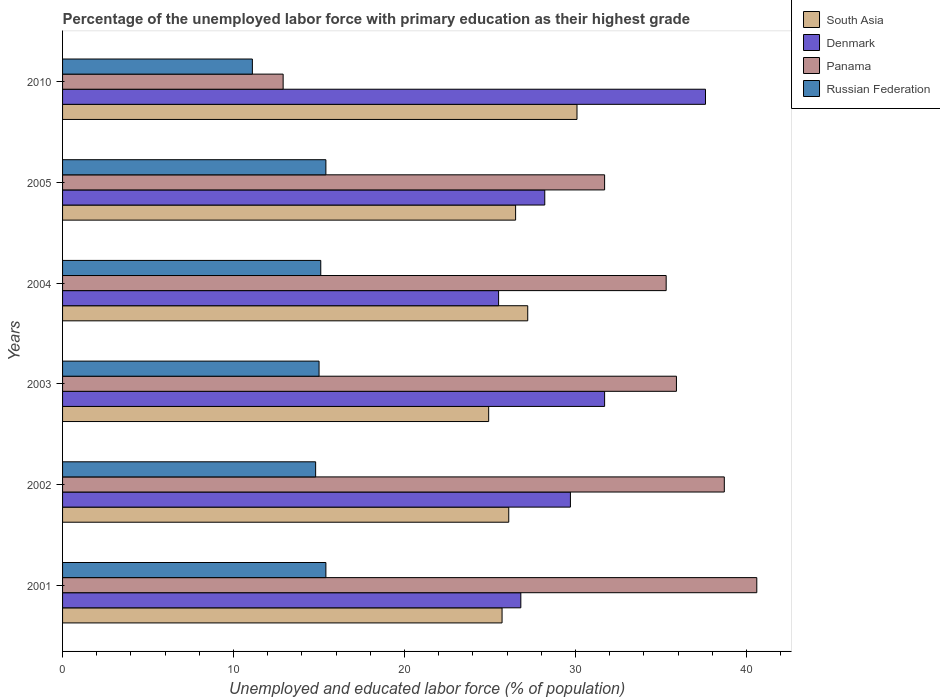How many different coloured bars are there?
Your answer should be very brief. 4. Are the number of bars per tick equal to the number of legend labels?
Make the answer very short. Yes. How many bars are there on the 4th tick from the top?
Offer a terse response. 4. How many bars are there on the 5th tick from the bottom?
Your answer should be very brief. 4. What is the label of the 6th group of bars from the top?
Offer a terse response. 2001. What is the percentage of the unemployed labor force with primary education in Denmark in 2010?
Your answer should be compact. 37.6. Across all years, what is the maximum percentage of the unemployed labor force with primary education in Russian Federation?
Provide a succinct answer. 15.4. Across all years, what is the minimum percentage of the unemployed labor force with primary education in South Asia?
Provide a short and direct response. 24.92. In which year was the percentage of the unemployed labor force with primary education in South Asia maximum?
Your response must be concise. 2010. What is the total percentage of the unemployed labor force with primary education in Denmark in the graph?
Your answer should be very brief. 179.5. What is the difference between the percentage of the unemployed labor force with primary education in Russian Federation in 2004 and that in 2010?
Ensure brevity in your answer.  4. What is the difference between the percentage of the unemployed labor force with primary education in Panama in 2005 and the percentage of the unemployed labor force with primary education in South Asia in 2001?
Give a very brief answer. 6. What is the average percentage of the unemployed labor force with primary education in Panama per year?
Your answer should be compact. 32.52. In the year 2003, what is the difference between the percentage of the unemployed labor force with primary education in Russian Federation and percentage of the unemployed labor force with primary education in Panama?
Provide a succinct answer. -20.9. What is the ratio of the percentage of the unemployed labor force with primary education in Denmark in 2005 to that in 2010?
Ensure brevity in your answer.  0.75. Is the percentage of the unemployed labor force with primary education in Denmark in 2001 less than that in 2004?
Give a very brief answer. No. What is the difference between the highest and the second highest percentage of the unemployed labor force with primary education in Denmark?
Offer a very short reply. 5.9. What is the difference between the highest and the lowest percentage of the unemployed labor force with primary education in South Asia?
Ensure brevity in your answer.  5.17. In how many years, is the percentage of the unemployed labor force with primary education in Denmark greater than the average percentage of the unemployed labor force with primary education in Denmark taken over all years?
Provide a succinct answer. 2. Is the sum of the percentage of the unemployed labor force with primary education in Panama in 2004 and 2005 greater than the maximum percentage of the unemployed labor force with primary education in Denmark across all years?
Ensure brevity in your answer.  Yes. What does the 2nd bar from the top in 2001 represents?
Your answer should be compact. Panama. What does the 1st bar from the bottom in 2003 represents?
Make the answer very short. South Asia. Are all the bars in the graph horizontal?
Give a very brief answer. Yes. What is the difference between two consecutive major ticks on the X-axis?
Your answer should be very brief. 10. Does the graph contain grids?
Your answer should be very brief. No. How many legend labels are there?
Ensure brevity in your answer.  4. How are the legend labels stacked?
Give a very brief answer. Vertical. What is the title of the graph?
Provide a short and direct response. Percentage of the unemployed labor force with primary education as their highest grade. Does "Vietnam" appear as one of the legend labels in the graph?
Make the answer very short. No. What is the label or title of the X-axis?
Offer a terse response. Unemployed and educated labor force (% of population). What is the label or title of the Y-axis?
Your response must be concise. Years. What is the Unemployed and educated labor force (% of population) in South Asia in 2001?
Your answer should be compact. 25.7. What is the Unemployed and educated labor force (% of population) of Denmark in 2001?
Keep it short and to the point. 26.8. What is the Unemployed and educated labor force (% of population) in Panama in 2001?
Provide a short and direct response. 40.6. What is the Unemployed and educated labor force (% of population) of Russian Federation in 2001?
Your answer should be compact. 15.4. What is the Unemployed and educated labor force (% of population) of South Asia in 2002?
Your answer should be very brief. 26.09. What is the Unemployed and educated labor force (% of population) of Denmark in 2002?
Offer a terse response. 29.7. What is the Unemployed and educated labor force (% of population) in Panama in 2002?
Offer a very short reply. 38.7. What is the Unemployed and educated labor force (% of population) of Russian Federation in 2002?
Make the answer very short. 14.8. What is the Unemployed and educated labor force (% of population) of South Asia in 2003?
Your answer should be compact. 24.92. What is the Unemployed and educated labor force (% of population) in Denmark in 2003?
Keep it short and to the point. 31.7. What is the Unemployed and educated labor force (% of population) in Panama in 2003?
Provide a short and direct response. 35.9. What is the Unemployed and educated labor force (% of population) in Russian Federation in 2003?
Your answer should be very brief. 15. What is the Unemployed and educated labor force (% of population) in South Asia in 2004?
Give a very brief answer. 27.2. What is the Unemployed and educated labor force (% of population) of Denmark in 2004?
Your answer should be compact. 25.5. What is the Unemployed and educated labor force (% of population) in Panama in 2004?
Your answer should be compact. 35.3. What is the Unemployed and educated labor force (% of population) of Russian Federation in 2004?
Provide a succinct answer. 15.1. What is the Unemployed and educated labor force (% of population) of South Asia in 2005?
Keep it short and to the point. 26.5. What is the Unemployed and educated labor force (% of population) of Denmark in 2005?
Give a very brief answer. 28.2. What is the Unemployed and educated labor force (% of population) of Panama in 2005?
Your response must be concise. 31.7. What is the Unemployed and educated labor force (% of population) of Russian Federation in 2005?
Give a very brief answer. 15.4. What is the Unemployed and educated labor force (% of population) in South Asia in 2010?
Give a very brief answer. 30.08. What is the Unemployed and educated labor force (% of population) in Denmark in 2010?
Your answer should be compact. 37.6. What is the Unemployed and educated labor force (% of population) in Panama in 2010?
Provide a succinct answer. 12.9. What is the Unemployed and educated labor force (% of population) of Russian Federation in 2010?
Give a very brief answer. 11.1. Across all years, what is the maximum Unemployed and educated labor force (% of population) of South Asia?
Make the answer very short. 30.08. Across all years, what is the maximum Unemployed and educated labor force (% of population) in Denmark?
Your answer should be compact. 37.6. Across all years, what is the maximum Unemployed and educated labor force (% of population) in Panama?
Provide a succinct answer. 40.6. Across all years, what is the maximum Unemployed and educated labor force (% of population) in Russian Federation?
Provide a succinct answer. 15.4. Across all years, what is the minimum Unemployed and educated labor force (% of population) of South Asia?
Provide a short and direct response. 24.92. Across all years, what is the minimum Unemployed and educated labor force (% of population) in Denmark?
Provide a short and direct response. 25.5. Across all years, what is the minimum Unemployed and educated labor force (% of population) in Panama?
Your answer should be very brief. 12.9. Across all years, what is the minimum Unemployed and educated labor force (% of population) in Russian Federation?
Provide a succinct answer. 11.1. What is the total Unemployed and educated labor force (% of population) in South Asia in the graph?
Provide a succinct answer. 160.5. What is the total Unemployed and educated labor force (% of population) in Denmark in the graph?
Ensure brevity in your answer.  179.5. What is the total Unemployed and educated labor force (% of population) of Panama in the graph?
Offer a terse response. 195.1. What is the total Unemployed and educated labor force (% of population) of Russian Federation in the graph?
Make the answer very short. 86.8. What is the difference between the Unemployed and educated labor force (% of population) of South Asia in 2001 and that in 2002?
Keep it short and to the point. -0.39. What is the difference between the Unemployed and educated labor force (% of population) of Denmark in 2001 and that in 2002?
Keep it short and to the point. -2.9. What is the difference between the Unemployed and educated labor force (% of population) in South Asia in 2001 and that in 2003?
Your answer should be very brief. 0.78. What is the difference between the Unemployed and educated labor force (% of population) in South Asia in 2001 and that in 2004?
Make the answer very short. -1.5. What is the difference between the Unemployed and educated labor force (% of population) in Panama in 2001 and that in 2004?
Your answer should be compact. 5.3. What is the difference between the Unemployed and educated labor force (% of population) in Russian Federation in 2001 and that in 2004?
Your answer should be very brief. 0.3. What is the difference between the Unemployed and educated labor force (% of population) of South Asia in 2001 and that in 2005?
Your answer should be compact. -0.79. What is the difference between the Unemployed and educated labor force (% of population) of Panama in 2001 and that in 2005?
Give a very brief answer. 8.9. What is the difference between the Unemployed and educated labor force (% of population) in South Asia in 2001 and that in 2010?
Ensure brevity in your answer.  -4.38. What is the difference between the Unemployed and educated labor force (% of population) in Denmark in 2001 and that in 2010?
Keep it short and to the point. -10.8. What is the difference between the Unemployed and educated labor force (% of population) of Panama in 2001 and that in 2010?
Offer a terse response. 27.7. What is the difference between the Unemployed and educated labor force (% of population) in South Asia in 2002 and that in 2003?
Offer a very short reply. 1.17. What is the difference between the Unemployed and educated labor force (% of population) in Denmark in 2002 and that in 2003?
Give a very brief answer. -2. What is the difference between the Unemployed and educated labor force (% of population) of Russian Federation in 2002 and that in 2003?
Your answer should be compact. -0.2. What is the difference between the Unemployed and educated labor force (% of population) in South Asia in 2002 and that in 2004?
Give a very brief answer. -1.11. What is the difference between the Unemployed and educated labor force (% of population) in Denmark in 2002 and that in 2004?
Make the answer very short. 4.2. What is the difference between the Unemployed and educated labor force (% of population) in Panama in 2002 and that in 2004?
Offer a very short reply. 3.4. What is the difference between the Unemployed and educated labor force (% of population) in Russian Federation in 2002 and that in 2004?
Offer a terse response. -0.3. What is the difference between the Unemployed and educated labor force (% of population) of South Asia in 2002 and that in 2005?
Make the answer very short. -0.4. What is the difference between the Unemployed and educated labor force (% of population) of South Asia in 2002 and that in 2010?
Provide a short and direct response. -3.99. What is the difference between the Unemployed and educated labor force (% of population) in Denmark in 2002 and that in 2010?
Offer a very short reply. -7.9. What is the difference between the Unemployed and educated labor force (% of population) of Panama in 2002 and that in 2010?
Provide a succinct answer. 25.8. What is the difference between the Unemployed and educated labor force (% of population) in South Asia in 2003 and that in 2004?
Keep it short and to the point. -2.28. What is the difference between the Unemployed and educated labor force (% of population) of Denmark in 2003 and that in 2004?
Ensure brevity in your answer.  6.2. What is the difference between the Unemployed and educated labor force (% of population) of Russian Federation in 2003 and that in 2004?
Make the answer very short. -0.1. What is the difference between the Unemployed and educated labor force (% of population) of South Asia in 2003 and that in 2005?
Give a very brief answer. -1.58. What is the difference between the Unemployed and educated labor force (% of population) in Panama in 2003 and that in 2005?
Provide a short and direct response. 4.2. What is the difference between the Unemployed and educated labor force (% of population) in Russian Federation in 2003 and that in 2005?
Offer a terse response. -0.4. What is the difference between the Unemployed and educated labor force (% of population) of South Asia in 2003 and that in 2010?
Give a very brief answer. -5.17. What is the difference between the Unemployed and educated labor force (% of population) in Denmark in 2003 and that in 2010?
Provide a succinct answer. -5.9. What is the difference between the Unemployed and educated labor force (% of population) of Panama in 2003 and that in 2010?
Give a very brief answer. 23. What is the difference between the Unemployed and educated labor force (% of population) of Russian Federation in 2003 and that in 2010?
Your response must be concise. 3.9. What is the difference between the Unemployed and educated labor force (% of population) in South Asia in 2004 and that in 2005?
Your answer should be compact. 0.71. What is the difference between the Unemployed and educated labor force (% of population) of Denmark in 2004 and that in 2005?
Your answer should be very brief. -2.7. What is the difference between the Unemployed and educated labor force (% of population) in Panama in 2004 and that in 2005?
Give a very brief answer. 3.6. What is the difference between the Unemployed and educated labor force (% of population) in South Asia in 2004 and that in 2010?
Provide a succinct answer. -2.88. What is the difference between the Unemployed and educated labor force (% of population) of Denmark in 2004 and that in 2010?
Keep it short and to the point. -12.1. What is the difference between the Unemployed and educated labor force (% of population) of Panama in 2004 and that in 2010?
Your response must be concise. 22.4. What is the difference between the Unemployed and educated labor force (% of population) of Russian Federation in 2004 and that in 2010?
Provide a short and direct response. 4. What is the difference between the Unemployed and educated labor force (% of population) in South Asia in 2005 and that in 2010?
Provide a short and direct response. -3.59. What is the difference between the Unemployed and educated labor force (% of population) of Denmark in 2005 and that in 2010?
Keep it short and to the point. -9.4. What is the difference between the Unemployed and educated labor force (% of population) in Panama in 2005 and that in 2010?
Give a very brief answer. 18.8. What is the difference between the Unemployed and educated labor force (% of population) of South Asia in 2001 and the Unemployed and educated labor force (% of population) of Denmark in 2002?
Your response must be concise. -4. What is the difference between the Unemployed and educated labor force (% of population) of South Asia in 2001 and the Unemployed and educated labor force (% of population) of Panama in 2002?
Provide a short and direct response. -13. What is the difference between the Unemployed and educated labor force (% of population) of South Asia in 2001 and the Unemployed and educated labor force (% of population) of Russian Federation in 2002?
Give a very brief answer. 10.9. What is the difference between the Unemployed and educated labor force (% of population) in Denmark in 2001 and the Unemployed and educated labor force (% of population) in Russian Federation in 2002?
Your answer should be compact. 12. What is the difference between the Unemployed and educated labor force (% of population) of Panama in 2001 and the Unemployed and educated labor force (% of population) of Russian Federation in 2002?
Provide a succinct answer. 25.8. What is the difference between the Unemployed and educated labor force (% of population) of South Asia in 2001 and the Unemployed and educated labor force (% of population) of Denmark in 2003?
Provide a succinct answer. -6. What is the difference between the Unemployed and educated labor force (% of population) of South Asia in 2001 and the Unemployed and educated labor force (% of population) of Panama in 2003?
Ensure brevity in your answer.  -10.2. What is the difference between the Unemployed and educated labor force (% of population) in South Asia in 2001 and the Unemployed and educated labor force (% of population) in Russian Federation in 2003?
Your answer should be compact. 10.7. What is the difference between the Unemployed and educated labor force (% of population) in Denmark in 2001 and the Unemployed and educated labor force (% of population) in Russian Federation in 2003?
Provide a short and direct response. 11.8. What is the difference between the Unemployed and educated labor force (% of population) of Panama in 2001 and the Unemployed and educated labor force (% of population) of Russian Federation in 2003?
Make the answer very short. 25.6. What is the difference between the Unemployed and educated labor force (% of population) of South Asia in 2001 and the Unemployed and educated labor force (% of population) of Denmark in 2004?
Keep it short and to the point. 0.2. What is the difference between the Unemployed and educated labor force (% of population) in South Asia in 2001 and the Unemployed and educated labor force (% of population) in Panama in 2004?
Provide a short and direct response. -9.6. What is the difference between the Unemployed and educated labor force (% of population) in South Asia in 2001 and the Unemployed and educated labor force (% of population) in Russian Federation in 2004?
Your response must be concise. 10.6. What is the difference between the Unemployed and educated labor force (% of population) of Panama in 2001 and the Unemployed and educated labor force (% of population) of Russian Federation in 2004?
Your response must be concise. 25.5. What is the difference between the Unemployed and educated labor force (% of population) of South Asia in 2001 and the Unemployed and educated labor force (% of population) of Denmark in 2005?
Your answer should be very brief. -2.5. What is the difference between the Unemployed and educated labor force (% of population) of South Asia in 2001 and the Unemployed and educated labor force (% of population) of Panama in 2005?
Provide a succinct answer. -6. What is the difference between the Unemployed and educated labor force (% of population) in South Asia in 2001 and the Unemployed and educated labor force (% of population) in Russian Federation in 2005?
Give a very brief answer. 10.3. What is the difference between the Unemployed and educated labor force (% of population) in Denmark in 2001 and the Unemployed and educated labor force (% of population) in Panama in 2005?
Offer a very short reply. -4.9. What is the difference between the Unemployed and educated labor force (% of population) of Panama in 2001 and the Unemployed and educated labor force (% of population) of Russian Federation in 2005?
Ensure brevity in your answer.  25.2. What is the difference between the Unemployed and educated labor force (% of population) of South Asia in 2001 and the Unemployed and educated labor force (% of population) of Denmark in 2010?
Your response must be concise. -11.9. What is the difference between the Unemployed and educated labor force (% of population) in South Asia in 2001 and the Unemployed and educated labor force (% of population) in Panama in 2010?
Ensure brevity in your answer.  12.8. What is the difference between the Unemployed and educated labor force (% of population) in South Asia in 2001 and the Unemployed and educated labor force (% of population) in Russian Federation in 2010?
Offer a very short reply. 14.6. What is the difference between the Unemployed and educated labor force (% of population) in Panama in 2001 and the Unemployed and educated labor force (% of population) in Russian Federation in 2010?
Provide a short and direct response. 29.5. What is the difference between the Unemployed and educated labor force (% of population) in South Asia in 2002 and the Unemployed and educated labor force (% of population) in Denmark in 2003?
Ensure brevity in your answer.  -5.61. What is the difference between the Unemployed and educated labor force (% of population) in South Asia in 2002 and the Unemployed and educated labor force (% of population) in Panama in 2003?
Provide a succinct answer. -9.81. What is the difference between the Unemployed and educated labor force (% of population) of South Asia in 2002 and the Unemployed and educated labor force (% of population) of Russian Federation in 2003?
Your response must be concise. 11.09. What is the difference between the Unemployed and educated labor force (% of population) in Panama in 2002 and the Unemployed and educated labor force (% of population) in Russian Federation in 2003?
Provide a short and direct response. 23.7. What is the difference between the Unemployed and educated labor force (% of population) of South Asia in 2002 and the Unemployed and educated labor force (% of population) of Denmark in 2004?
Ensure brevity in your answer.  0.59. What is the difference between the Unemployed and educated labor force (% of population) in South Asia in 2002 and the Unemployed and educated labor force (% of population) in Panama in 2004?
Offer a terse response. -9.21. What is the difference between the Unemployed and educated labor force (% of population) of South Asia in 2002 and the Unemployed and educated labor force (% of population) of Russian Federation in 2004?
Your response must be concise. 10.99. What is the difference between the Unemployed and educated labor force (% of population) in Denmark in 2002 and the Unemployed and educated labor force (% of population) in Panama in 2004?
Your answer should be compact. -5.6. What is the difference between the Unemployed and educated labor force (% of population) in Panama in 2002 and the Unemployed and educated labor force (% of population) in Russian Federation in 2004?
Offer a terse response. 23.6. What is the difference between the Unemployed and educated labor force (% of population) in South Asia in 2002 and the Unemployed and educated labor force (% of population) in Denmark in 2005?
Give a very brief answer. -2.11. What is the difference between the Unemployed and educated labor force (% of population) in South Asia in 2002 and the Unemployed and educated labor force (% of population) in Panama in 2005?
Provide a succinct answer. -5.61. What is the difference between the Unemployed and educated labor force (% of population) in South Asia in 2002 and the Unemployed and educated labor force (% of population) in Russian Federation in 2005?
Offer a terse response. 10.69. What is the difference between the Unemployed and educated labor force (% of population) of Denmark in 2002 and the Unemployed and educated labor force (% of population) of Panama in 2005?
Provide a short and direct response. -2. What is the difference between the Unemployed and educated labor force (% of population) of Panama in 2002 and the Unemployed and educated labor force (% of population) of Russian Federation in 2005?
Provide a short and direct response. 23.3. What is the difference between the Unemployed and educated labor force (% of population) in South Asia in 2002 and the Unemployed and educated labor force (% of population) in Denmark in 2010?
Keep it short and to the point. -11.51. What is the difference between the Unemployed and educated labor force (% of population) of South Asia in 2002 and the Unemployed and educated labor force (% of population) of Panama in 2010?
Ensure brevity in your answer.  13.19. What is the difference between the Unemployed and educated labor force (% of population) of South Asia in 2002 and the Unemployed and educated labor force (% of population) of Russian Federation in 2010?
Your answer should be compact. 14.99. What is the difference between the Unemployed and educated labor force (% of population) of Denmark in 2002 and the Unemployed and educated labor force (% of population) of Russian Federation in 2010?
Offer a terse response. 18.6. What is the difference between the Unemployed and educated labor force (% of population) of Panama in 2002 and the Unemployed and educated labor force (% of population) of Russian Federation in 2010?
Your answer should be compact. 27.6. What is the difference between the Unemployed and educated labor force (% of population) in South Asia in 2003 and the Unemployed and educated labor force (% of population) in Denmark in 2004?
Provide a succinct answer. -0.58. What is the difference between the Unemployed and educated labor force (% of population) in South Asia in 2003 and the Unemployed and educated labor force (% of population) in Panama in 2004?
Provide a short and direct response. -10.38. What is the difference between the Unemployed and educated labor force (% of population) in South Asia in 2003 and the Unemployed and educated labor force (% of population) in Russian Federation in 2004?
Your response must be concise. 9.82. What is the difference between the Unemployed and educated labor force (% of population) in Panama in 2003 and the Unemployed and educated labor force (% of population) in Russian Federation in 2004?
Offer a very short reply. 20.8. What is the difference between the Unemployed and educated labor force (% of population) in South Asia in 2003 and the Unemployed and educated labor force (% of population) in Denmark in 2005?
Your answer should be very brief. -3.28. What is the difference between the Unemployed and educated labor force (% of population) in South Asia in 2003 and the Unemployed and educated labor force (% of population) in Panama in 2005?
Your answer should be compact. -6.78. What is the difference between the Unemployed and educated labor force (% of population) in South Asia in 2003 and the Unemployed and educated labor force (% of population) in Russian Federation in 2005?
Offer a very short reply. 9.52. What is the difference between the Unemployed and educated labor force (% of population) of Panama in 2003 and the Unemployed and educated labor force (% of population) of Russian Federation in 2005?
Provide a succinct answer. 20.5. What is the difference between the Unemployed and educated labor force (% of population) in South Asia in 2003 and the Unemployed and educated labor force (% of population) in Denmark in 2010?
Your answer should be very brief. -12.68. What is the difference between the Unemployed and educated labor force (% of population) in South Asia in 2003 and the Unemployed and educated labor force (% of population) in Panama in 2010?
Give a very brief answer. 12.02. What is the difference between the Unemployed and educated labor force (% of population) in South Asia in 2003 and the Unemployed and educated labor force (% of population) in Russian Federation in 2010?
Ensure brevity in your answer.  13.82. What is the difference between the Unemployed and educated labor force (% of population) of Denmark in 2003 and the Unemployed and educated labor force (% of population) of Panama in 2010?
Offer a very short reply. 18.8. What is the difference between the Unemployed and educated labor force (% of population) of Denmark in 2003 and the Unemployed and educated labor force (% of population) of Russian Federation in 2010?
Give a very brief answer. 20.6. What is the difference between the Unemployed and educated labor force (% of population) of Panama in 2003 and the Unemployed and educated labor force (% of population) of Russian Federation in 2010?
Your answer should be very brief. 24.8. What is the difference between the Unemployed and educated labor force (% of population) in South Asia in 2004 and the Unemployed and educated labor force (% of population) in Denmark in 2005?
Offer a terse response. -1. What is the difference between the Unemployed and educated labor force (% of population) of South Asia in 2004 and the Unemployed and educated labor force (% of population) of Panama in 2005?
Your answer should be very brief. -4.5. What is the difference between the Unemployed and educated labor force (% of population) in South Asia in 2004 and the Unemployed and educated labor force (% of population) in Russian Federation in 2005?
Your answer should be compact. 11.8. What is the difference between the Unemployed and educated labor force (% of population) in South Asia in 2004 and the Unemployed and educated labor force (% of population) in Denmark in 2010?
Your answer should be compact. -10.4. What is the difference between the Unemployed and educated labor force (% of population) in South Asia in 2004 and the Unemployed and educated labor force (% of population) in Panama in 2010?
Keep it short and to the point. 14.3. What is the difference between the Unemployed and educated labor force (% of population) of South Asia in 2004 and the Unemployed and educated labor force (% of population) of Russian Federation in 2010?
Your answer should be compact. 16.1. What is the difference between the Unemployed and educated labor force (% of population) in Denmark in 2004 and the Unemployed and educated labor force (% of population) in Panama in 2010?
Provide a short and direct response. 12.6. What is the difference between the Unemployed and educated labor force (% of population) of Panama in 2004 and the Unemployed and educated labor force (% of population) of Russian Federation in 2010?
Your response must be concise. 24.2. What is the difference between the Unemployed and educated labor force (% of population) in South Asia in 2005 and the Unemployed and educated labor force (% of population) in Denmark in 2010?
Your answer should be very brief. -11.1. What is the difference between the Unemployed and educated labor force (% of population) of South Asia in 2005 and the Unemployed and educated labor force (% of population) of Panama in 2010?
Provide a succinct answer. 13.6. What is the difference between the Unemployed and educated labor force (% of population) of South Asia in 2005 and the Unemployed and educated labor force (% of population) of Russian Federation in 2010?
Your answer should be compact. 15.4. What is the difference between the Unemployed and educated labor force (% of population) of Panama in 2005 and the Unemployed and educated labor force (% of population) of Russian Federation in 2010?
Provide a short and direct response. 20.6. What is the average Unemployed and educated labor force (% of population) in South Asia per year?
Your response must be concise. 26.75. What is the average Unemployed and educated labor force (% of population) in Denmark per year?
Make the answer very short. 29.92. What is the average Unemployed and educated labor force (% of population) of Panama per year?
Give a very brief answer. 32.52. What is the average Unemployed and educated labor force (% of population) in Russian Federation per year?
Offer a terse response. 14.47. In the year 2001, what is the difference between the Unemployed and educated labor force (% of population) in South Asia and Unemployed and educated labor force (% of population) in Denmark?
Keep it short and to the point. -1.1. In the year 2001, what is the difference between the Unemployed and educated labor force (% of population) in South Asia and Unemployed and educated labor force (% of population) in Panama?
Your answer should be very brief. -14.9. In the year 2001, what is the difference between the Unemployed and educated labor force (% of population) of South Asia and Unemployed and educated labor force (% of population) of Russian Federation?
Offer a very short reply. 10.3. In the year 2001, what is the difference between the Unemployed and educated labor force (% of population) in Denmark and Unemployed and educated labor force (% of population) in Panama?
Your answer should be compact. -13.8. In the year 2001, what is the difference between the Unemployed and educated labor force (% of population) in Denmark and Unemployed and educated labor force (% of population) in Russian Federation?
Keep it short and to the point. 11.4. In the year 2001, what is the difference between the Unemployed and educated labor force (% of population) in Panama and Unemployed and educated labor force (% of population) in Russian Federation?
Offer a terse response. 25.2. In the year 2002, what is the difference between the Unemployed and educated labor force (% of population) of South Asia and Unemployed and educated labor force (% of population) of Denmark?
Make the answer very short. -3.61. In the year 2002, what is the difference between the Unemployed and educated labor force (% of population) in South Asia and Unemployed and educated labor force (% of population) in Panama?
Give a very brief answer. -12.61. In the year 2002, what is the difference between the Unemployed and educated labor force (% of population) in South Asia and Unemployed and educated labor force (% of population) in Russian Federation?
Provide a succinct answer. 11.29. In the year 2002, what is the difference between the Unemployed and educated labor force (% of population) in Denmark and Unemployed and educated labor force (% of population) in Russian Federation?
Keep it short and to the point. 14.9. In the year 2002, what is the difference between the Unemployed and educated labor force (% of population) of Panama and Unemployed and educated labor force (% of population) of Russian Federation?
Your answer should be very brief. 23.9. In the year 2003, what is the difference between the Unemployed and educated labor force (% of population) of South Asia and Unemployed and educated labor force (% of population) of Denmark?
Keep it short and to the point. -6.78. In the year 2003, what is the difference between the Unemployed and educated labor force (% of population) of South Asia and Unemployed and educated labor force (% of population) of Panama?
Provide a short and direct response. -10.98. In the year 2003, what is the difference between the Unemployed and educated labor force (% of population) in South Asia and Unemployed and educated labor force (% of population) in Russian Federation?
Ensure brevity in your answer.  9.92. In the year 2003, what is the difference between the Unemployed and educated labor force (% of population) of Denmark and Unemployed and educated labor force (% of population) of Russian Federation?
Offer a terse response. 16.7. In the year 2003, what is the difference between the Unemployed and educated labor force (% of population) in Panama and Unemployed and educated labor force (% of population) in Russian Federation?
Provide a short and direct response. 20.9. In the year 2004, what is the difference between the Unemployed and educated labor force (% of population) in South Asia and Unemployed and educated labor force (% of population) in Denmark?
Offer a very short reply. 1.7. In the year 2004, what is the difference between the Unemployed and educated labor force (% of population) of South Asia and Unemployed and educated labor force (% of population) of Panama?
Ensure brevity in your answer.  -8.1. In the year 2004, what is the difference between the Unemployed and educated labor force (% of population) in South Asia and Unemployed and educated labor force (% of population) in Russian Federation?
Your response must be concise. 12.1. In the year 2004, what is the difference between the Unemployed and educated labor force (% of population) in Panama and Unemployed and educated labor force (% of population) in Russian Federation?
Your answer should be compact. 20.2. In the year 2005, what is the difference between the Unemployed and educated labor force (% of population) in South Asia and Unemployed and educated labor force (% of population) in Denmark?
Make the answer very short. -1.7. In the year 2005, what is the difference between the Unemployed and educated labor force (% of population) in South Asia and Unemployed and educated labor force (% of population) in Panama?
Give a very brief answer. -5.2. In the year 2005, what is the difference between the Unemployed and educated labor force (% of population) in South Asia and Unemployed and educated labor force (% of population) in Russian Federation?
Provide a succinct answer. 11.1. In the year 2005, what is the difference between the Unemployed and educated labor force (% of population) of Denmark and Unemployed and educated labor force (% of population) of Panama?
Make the answer very short. -3.5. In the year 2005, what is the difference between the Unemployed and educated labor force (% of population) in Denmark and Unemployed and educated labor force (% of population) in Russian Federation?
Keep it short and to the point. 12.8. In the year 2010, what is the difference between the Unemployed and educated labor force (% of population) in South Asia and Unemployed and educated labor force (% of population) in Denmark?
Your answer should be very brief. -7.52. In the year 2010, what is the difference between the Unemployed and educated labor force (% of population) in South Asia and Unemployed and educated labor force (% of population) in Panama?
Ensure brevity in your answer.  17.18. In the year 2010, what is the difference between the Unemployed and educated labor force (% of population) in South Asia and Unemployed and educated labor force (% of population) in Russian Federation?
Offer a terse response. 18.98. In the year 2010, what is the difference between the Unemployed and educated labor force (% of population) in Denmark and Unemployed and educated labor force (% of population) in Panama?
Provide a short and direct response. 24.7. In the year 2010, what is the difference between the Unemployed and educated labor force (% of population) in Denmark and Unemployed and educated labor force (% of population) in Russian Federation?
Provide a succinct answer. 26.5. What is the ratio of the Unemployed and educated labor force (% of population) in South Asia in 2001 to that in 2002?
Make the answer very short. 0.98. What is the ratio of the Unemployed and educated labor force (% of population) in Denmark in 2001 to that in 2002?
Your response must be concise. 0.9. What is the ratio of the Unemployed and educated labor force (% of population) of Panama in 2001 to that in 2002?
Your answer should be very brief. 1.05. What is the ratio of the Unemployed and educated labor force (% of population) of Russian Federation in 2001 to that in 2002?
Provide a succinct answer. 1.04. What is the ratio of the Unemployed and educated labor force (% of population) of South Asia in 2001 to that in 2003?
Make the answer very short. 1.03. What is the ratio of the Unemployed and educated labor force (% of population) of Denmark in 2001 to that in 2003?
Offer a very short reply. 0.85. What is the ratio of the Unemployed and educated labor force (% of population) of Panama in 2001 to that in 2003?
Offer a terse response. 1.13. What is the ratio of the Unemployed and educated labor force (% of population) of Russian Federation in 2001 to that in 2003?
Give a very brief answer. 1.03. What is the ratio of the Unemployed and educated labor force (% of population) of South Asia in 2001 to that in 2004?
Offer a very short reply. 0.94. What is the ratio of the Unemployed and educated labor force (% of population) in Denmark in 2001 to that in 2004?
Provide a succinct answer. 1.05. What is the ratio of the Unemployed and educated labor force (% of population) in Panama in 2001 to that in 2004?
Your answer should be compact. 1.15. What is the ratio of the Unemployed and educated labor force (% of population) in Russian Federation in 2001 to that in 2004?
Make the answer very short. 1.02. What is the ratio of the Unemployed and educated labor force (% of population) in South Asia in 2001 to that in 2005?
Offer a very short reply. 0.97. What is the ratio of the Unemployed and educated labor force (% of population) of Denmark in 2001 to that in 2005?
Offer a terse response. 0.95. What is the ratio of the Unemployed and educated labor force (% of population) of Panama in 2001 to that in 2005?
Your answer should be very brief. 1.28. What is the ratio of the Unemployed and educated labor force (% of population) in Russian Federation in 2001 to that in 2005?
Keep it short and to the point. 1. What is the ratio of the Unemployed and educated labor force (% of population) in South Asia in 2001 to that in 2010?
Ensure brevity in your answer.  0.85. What is the ratio of the Unemployed and educated labor force (% of population) in Denmark in 2001 to that in 2010?
Your response must be concise. 0.71. What is the ratio of the Unemployed and educated labor force (% of population) of Panama in 2001 to that in 2010?
Offer a terse response. 3.15. What is the ratio of the Unemployed and educated labor force (% of population) of Russian Federation in 2001 to that in 2010?
Your answer should be compact. 1.39. What is the ratio of the Unemployed and educated labor force (% of population) in South Asia in 2002 to that in 2003?
Provide a succinct answer. 1.05. What is the ratio of the Unemployed and educated labor force (% of population) in Denmark in 2002 to that in 2003?
Ensure brevity in your answer.  0.94. What is the ratio of the Unemployed and educated labor force (% of population) in Panama in 2002 to that in 2003?
Your answer should be very brief. 1.08. What is the ratio of the Unemployed and educated labor force (% of population) of Russian Federation in 2002 to that in 2003?
Offer a terse response. 0.99. What is the ratio of the Unemployed and educated labor force (% of population) of South Asia in 2002 to that in 2004?
Ensure brevity in your answer.  0.96. What is the ratio of the Unemployed and educated labor force (% of population) of Denmark in 2002 to that in 2004?
Provide a short and direct response. 1.16. What is the ratio of the Unemployed and educated labor force (% of population) of Panama in 2002 to that in 2004?
Your answer should be compact. 1.1. What is the ratio of the Unemployed and educated labor force (% of population) in Russian Federation in 2002 to that in 2004?
Offer a very short reply. 0.98. What is the ratio of the Unemployed and educated labor force (% of population) in South Asia in 2002 to that in 2005?
Your answer should be compact. 0.98. What is the ratio of the Unemployed and educated labor force (% of population) in Denmark in 2002 to that in 2005?
Provide a short and direct response. 1.05. What is the ratio of the Unemployed and educated labor force (% of population) in Panama in 2002 to that in 2005?
Provide a succinct answer. 1.22. What is the ratio of the Unemployed and educated labor force (% of population) of South Asia in 2002 to that in 2010?
Your answer should be compact. 0.87. What is the ratio of the Unemployed and educated labor force (% of population) in Denmark in 2002 to that in 2010?
Offer a very short reply. 0.79. What is the ratio of the Unemployed and educated labor force (% of population) of Panama in 2002 to that in 2010?
Ensure brevity in your answer.  3. What is the ratio of the Unemployed and educated labor force (% of population) in South Asia in 2003 to that in 2004?
Offer a very short reply. 0.92. What is the ratio of the Unemployed and educated labor force (% of population) of Denmark in 2003 to that in 2004?
Provide a succinct answer. 1.24. What is the ratio of the Unemployed and educated labor force (% of population) of Panama in 2003 to that in 2004?
Your response must be concise. 1.02. What is the ratio of the Unemployed and educated labor force (% of population) in South Asia in 2003 to that in 2005?
Provide a succinct answer. 0.94. What is the ratio of the Unemployed and educated labor force (% of population) of Denmark in 2003 to that in 2005?
Make the answer very short. 1.12. What is the ratio of the Unemployed and educated labor force (% of population) of Panama in 2003 to that in 2005?
Provide a succinct answer. 1.13. What is the ratio of the Unemployed and educated labor force (% of population) in South Asia in 2003 to that in 2010?
Keep it short and to the point. 0.83. What is the ratio of the Unemployed and educated labor force (% of population) of Denmark in 2003 to that in 2010?
Offer a terse response. 0.84. What is the ratio of the Unemployed and educated labor force (% of population) of Panama in 2003 to that in 2010?
Give a very brief answer. 2.78. What is the ratio of the Unemployed and educated labor force (% of population) of Russian Federation in 2003 to that in 2010?
Ensure brevity in your answer.  1.35. What is the ratio of the Unemployed and educated labor force (% of population) of South Asia in 2004 to that in 2005?
Your answer should be compact. 1.03. What is the ratio of the Unemployed and educated labor force (% of population) in Denmark in 2004 to that in 2005?
Provide a short and direct response. 0.9. What is the ratio of the Unemployed and educated labor force (% of population) of Panama in 2004 to that in 2005?
Give a very brief answer. 1.11. What is the ratio of the Unemployed and educated labor force (% of population) in Russian Federation in 2004 to that in 2005?
Give a very brief answer. 0.98. What is the ratio of the Unemployed and educated labor force (% of population) in South Asia in 2004 to that in 2010?
Offer a very short reply. 0.9. What is the ratio of the Unemployed and educated labor force (% of population) in Denmark in 2004 to that in 2010?
Provide a short and direct response. 0.68. What is the ratio of the Unemployed and educated labor force (% of population) in Panama in 2004 to that in 2010?
Keep it short and to the point. 2.74. What is the ratio of the Unemployed and educated labor force (% of population) in Russian Federation in 2004 to that in 2010?
Offer a terse response. 1.36. What is the ratio of the Unemployed and educated labor force (% of population) of South Asia in 2005 to that in 2010?
Provide a short and direct response. 0.88. What is the ratio of the Unemployed and educated labor force (% of population) of Panama in 2005 to that in 2010?
Keep it short and to the point. 2.46. What is the ratio of the Unemployed and educated labor force (% of population) in Russian Federation in 2005 to that in 2010?
Give a very brief answer. 1.39. What is the difference between the highest and the second highest Unemployed and educated labor force (% of population) in South Asia?
Provide a short and direct response. 2.88. What is the difference between the highest and the second highest Unemployed and educated labor force (% of population) in Denmark?
Ensure brevity in your answer.  5.9. What is the difference between the highest and the second highest Unemployed and educated labor force (% of population) in Panama?
Provide a short and direct response. 1.9. What is the difference between the highest and the second highest Unemployed and educated labor force (% of population) of Russian Federation?
Your answer should be very brief. 0. What is the difference between the highest and the lowest Unemployed and educated labor force (% of population) of South Asia?
Your answer should be very brief. 5.17. What is the difference between the highest and the lowest Unemployed and educated labor force (% of population) of Panama?
Your answer should be very brief. 27.7. What is the difference between the highest and the lowest Unemployed and educated labor force (% of population) in Russian Federation?
Your answer should be compact. 4.3. 